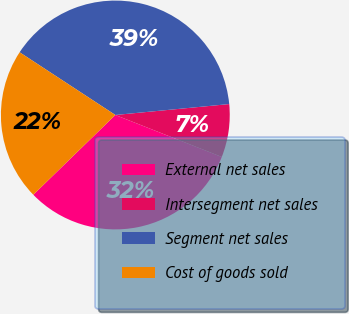<chart> <loc_0><loc_0><loc_500><loc_500><pie_chart><fcel>External net sales<fcel>Intersegment net sales<fcel>Segment net sales<fcel>Cost of goods sold<nl><fcel>31.75%<fcel>7.5%<fcel>39.25%<fcel>21.51%<nl></chart> 